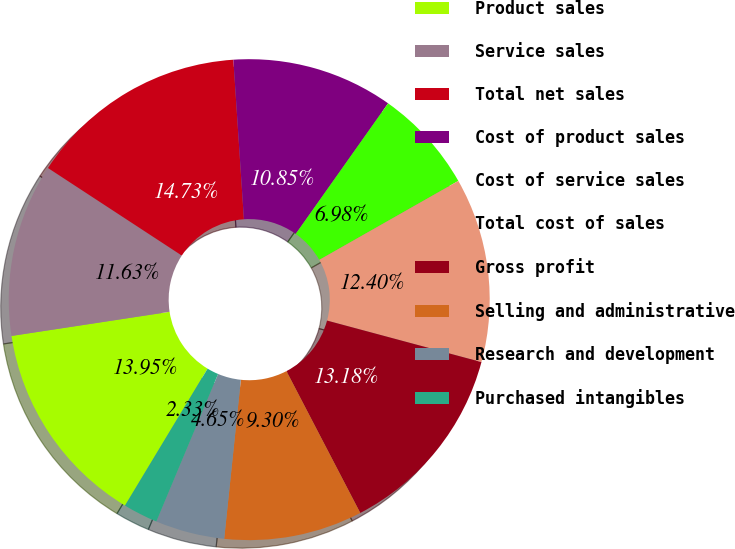Convert chart. <chart><loc_0><loc_0><loc_500><loc_500><pie_chart><fcel>Product sales<fcel>Service sales<fcel>Total net sales<fcel>Cost of product sales<fcel>Cost of service sales<fcel>Total cost of sales<fcel>Gross profit<fcel>Selling and administrative<fcel>Research and development<fcel>Purchased intangibles<nl><fcel>13.95%<fcel>11.63%<fcel>14.73%<fcel>10.85%<fcel>6.98%<fcel>12.4%<fcel>13.18%<fcel>9.3%<fcel>4.65%<fcel>2.33%<nl></chart> 